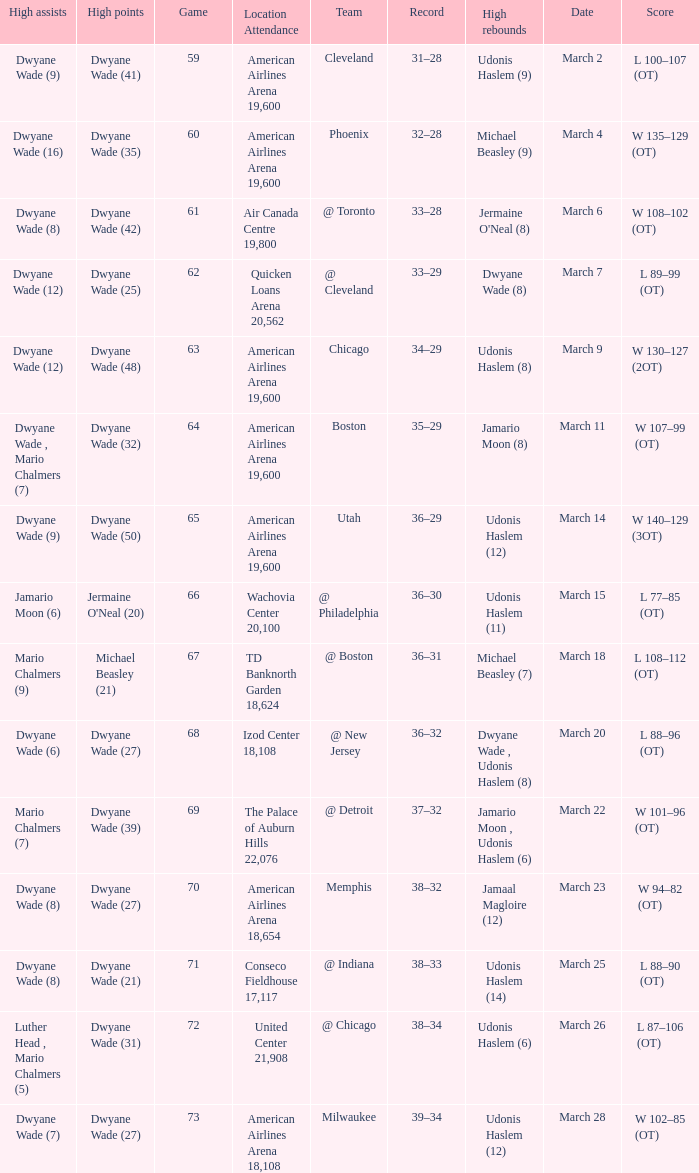What team(s) did they play on march 9? Chicago. 